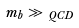Convert formula to latex. <formula><loc_0><loc_0><loc_500><loc_500>m _ { b } \gg \Lambda _ { Q C D }</formula> 